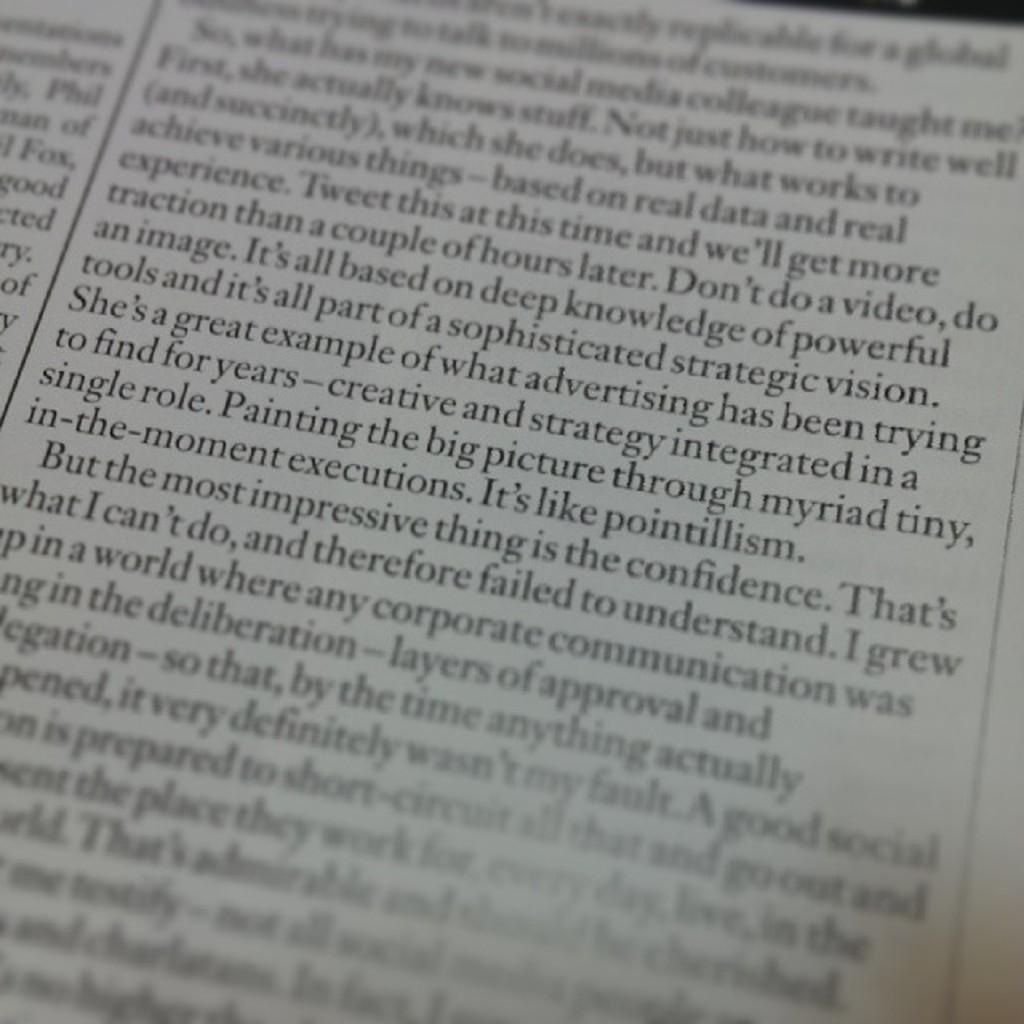What is present in the image that contains information or a message? There is a poster in the image. What can be found on the poster? The poster has text written on it. Can you describe the behavior of the lake in the image? There is no lake present in the image, so it is not possible to describe its behavior. 